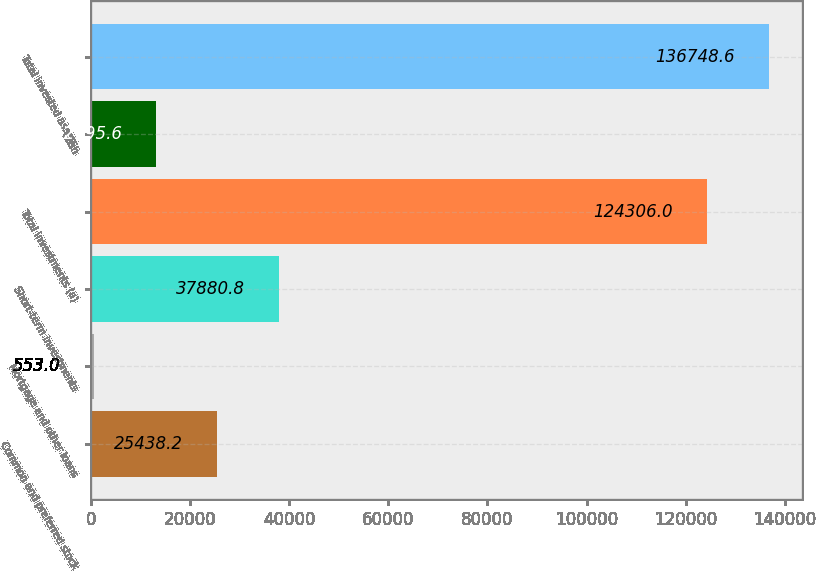Convert chart. <chart><loc_0><loc_0><loc_500><loc_500><bar_chart><fcel>Common and preferred stock<fcel>Mortgage and other loans<fcel>Short-term investments<fcel>Total investments (a)<fcel>Cash<fcel>Total invested assets<nl><fcel>25438.2<fcel>553<fcel>37880.8<fcel>124306<fcel>12995.6<fcel>136749<nl></chart> 